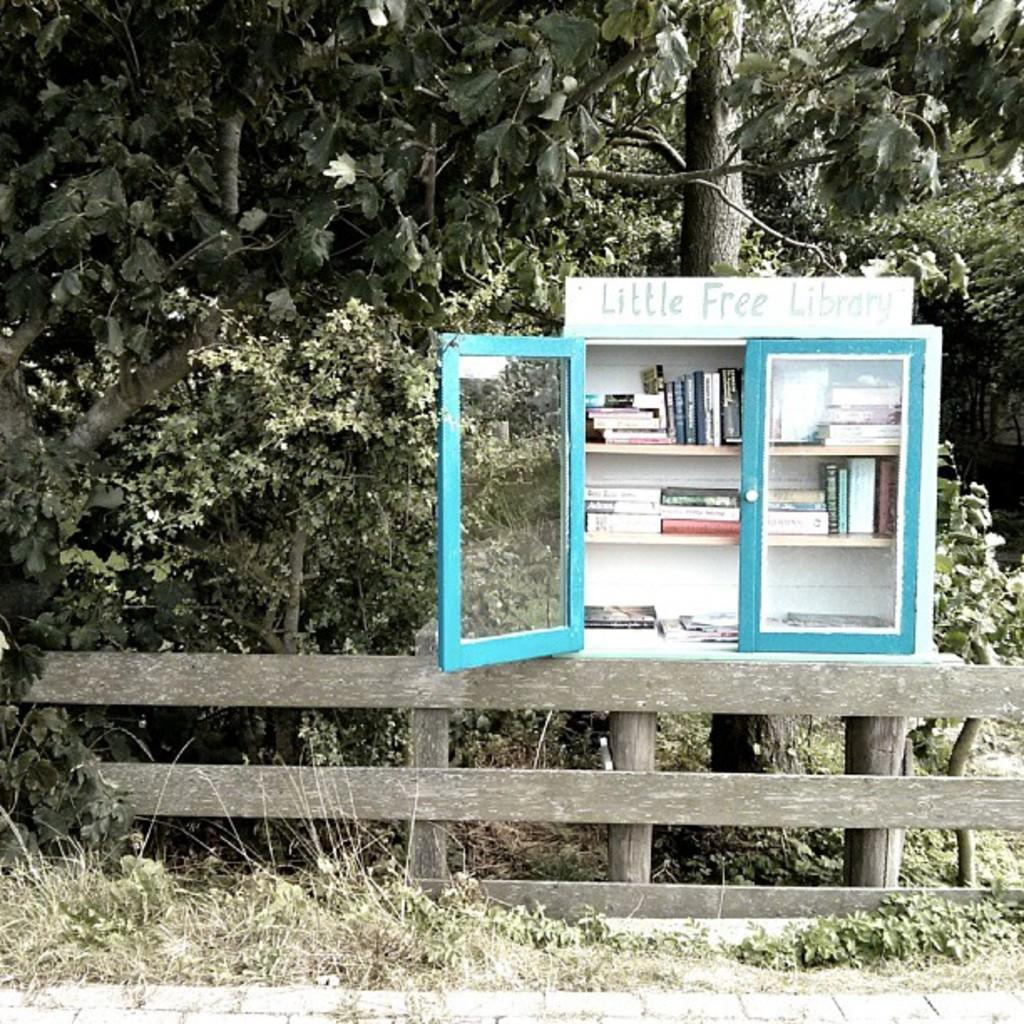<image>
Offer a succinct explanation of the picture presented. A small white and blue cabinet with book in the middle of nowhere that says little free Library. 